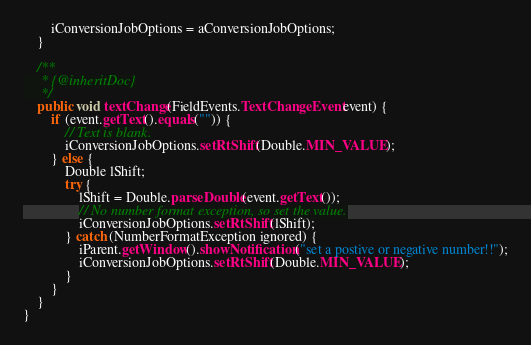Convert code to text. <code><loc_0><loc_0><loc_500><loc_500><_Java_>        iConversionJobOptions = aConversionJobOptions;
    }

    /**
     * {@inheritDoc}
     */
    public void textChange(FieldEvents.TextChangeEvent event) {
        if (event.getText().equals("")) {
            // Text is blank.
            iConversionJobOptions.setRtShift(Double.MIN_VALUE);
        } else {
            Double lShift;
            try {
                lShift = Double.parseDouble(event.getText());
                // No number format exception, so set the value.
                iConversionJobOptions.setRtShift(lShift);
            } catch (NumberFormatException ignored) {
                iParent.getWindow().showNotification("set a postive or negative number!!");
                iConversionJobOptions.setRtShift(Double.MIN_VALUE);
            }
        }
    }
}</code> 